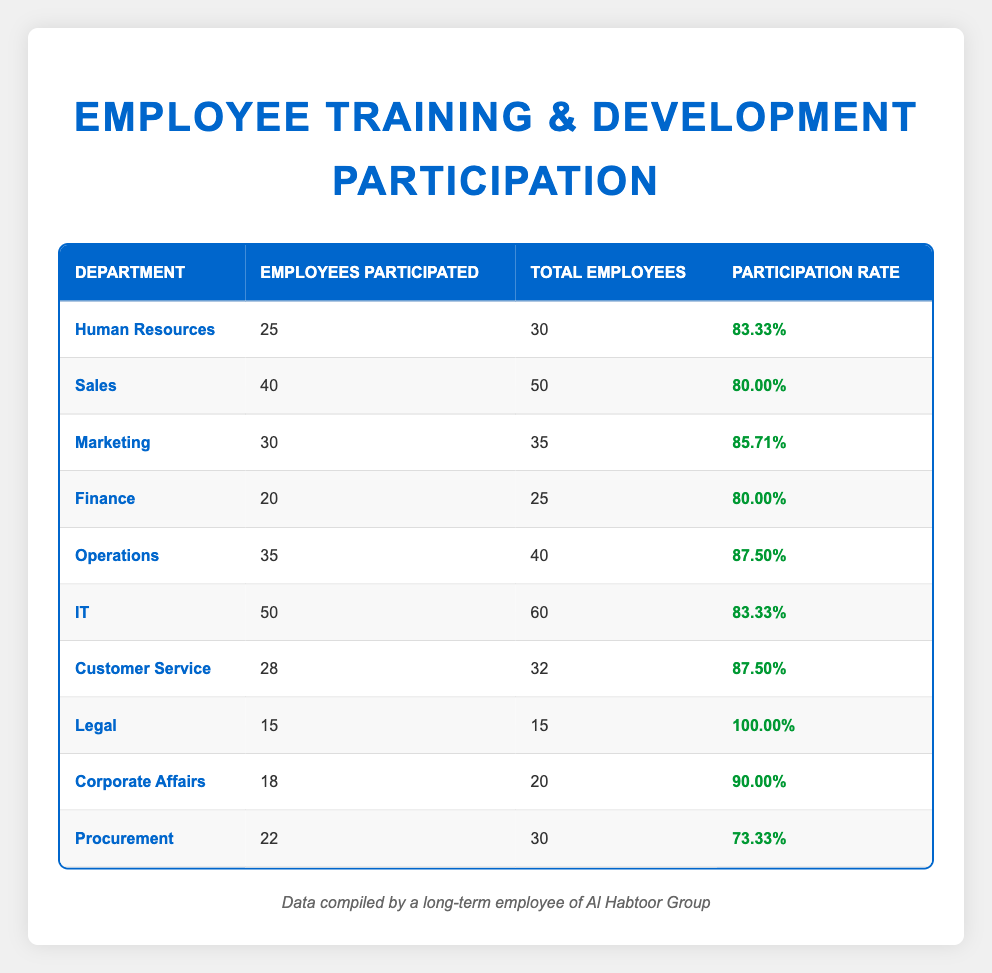What is the participation rate for the Legal department? The table shows that the Legal department has a participation rate of 100.00%.
Answer: 100.00% Which department had the highest number of employees participated? By checking the "Employees Participated" column, IT had the highest number with 50 employees participated.
Answer: IT How many total employees are there in the Procurement department? The table indicates that the total number of employees in the Procurement department is 30.
Answer: 30 What is the average participation rate of all departments? First, sum the participation rates: (83.33 + 80.00 + 85.71 + 80.00 + 87.50 + 83.33 + 87.50 + 100.00 + 90.00 + 73.33) =  870.00. There are 10 departments, so the average is 870.00/10 = 87.00.
Answer: 87.00 Is the participation rate for the Sales department above 75%? The Sales department has a participation rate of 80.00%, which is above 75%.
Answer: Yes How many more employees participated in Operations than in Finance? Operations had 35 employees who participated, while Finance had 20 participants. The difference is 35 - 20 = 15.
Answer: 15 Which department has a participation rate below 75%? The only department with a participation rate below 75% is Procurement, which has a participation rate of 73.33%.
Answer: Procurement Which department had the lowest participation rate and what is that rate? By reviewing the table, Procurement has the lowest participation rate at 73.33%.
Answer: Procurement, 73.33% How many total employees participated across all departments? Adding the employees participated from all departments yields: (25 + 40 + 30 + 20 + 35 + 50 + 28 + 15 + 18 + 22) =  268.
Answer: 268 